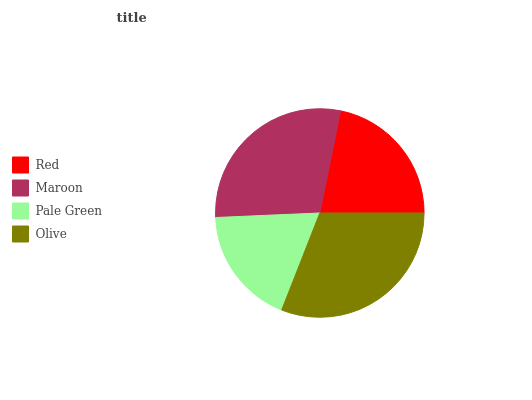Is Pale Green the minimum?
Answer yes or no. Yes. Is Olive the maximum?
Answer yes or no. Yes. Is Maroon the minimum?
Answer yes or no. No. Is Maroon the maximum?
Answer yes or no. No. Is Maroon greater than Red?
Answer yes or no. Yes. Is Red less than Maroon?
Answer yes or no. Yes. Is Red greater than Maroon?
Answer yes or no. No. Is Maroon less than Red?
Answer yes or no. No. Is Maroon the high median?
Answer yes or no. Yes. Is Red the low median?
Answer yes or no. Yes. Is Olive the high median?
Answer yes or no. No. Is Pale Green the low median?
Answer yes or no. No. 